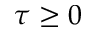<formula> <loc_0><loc_0><loc_500><loc_500>\tau \geq 0</formula> 